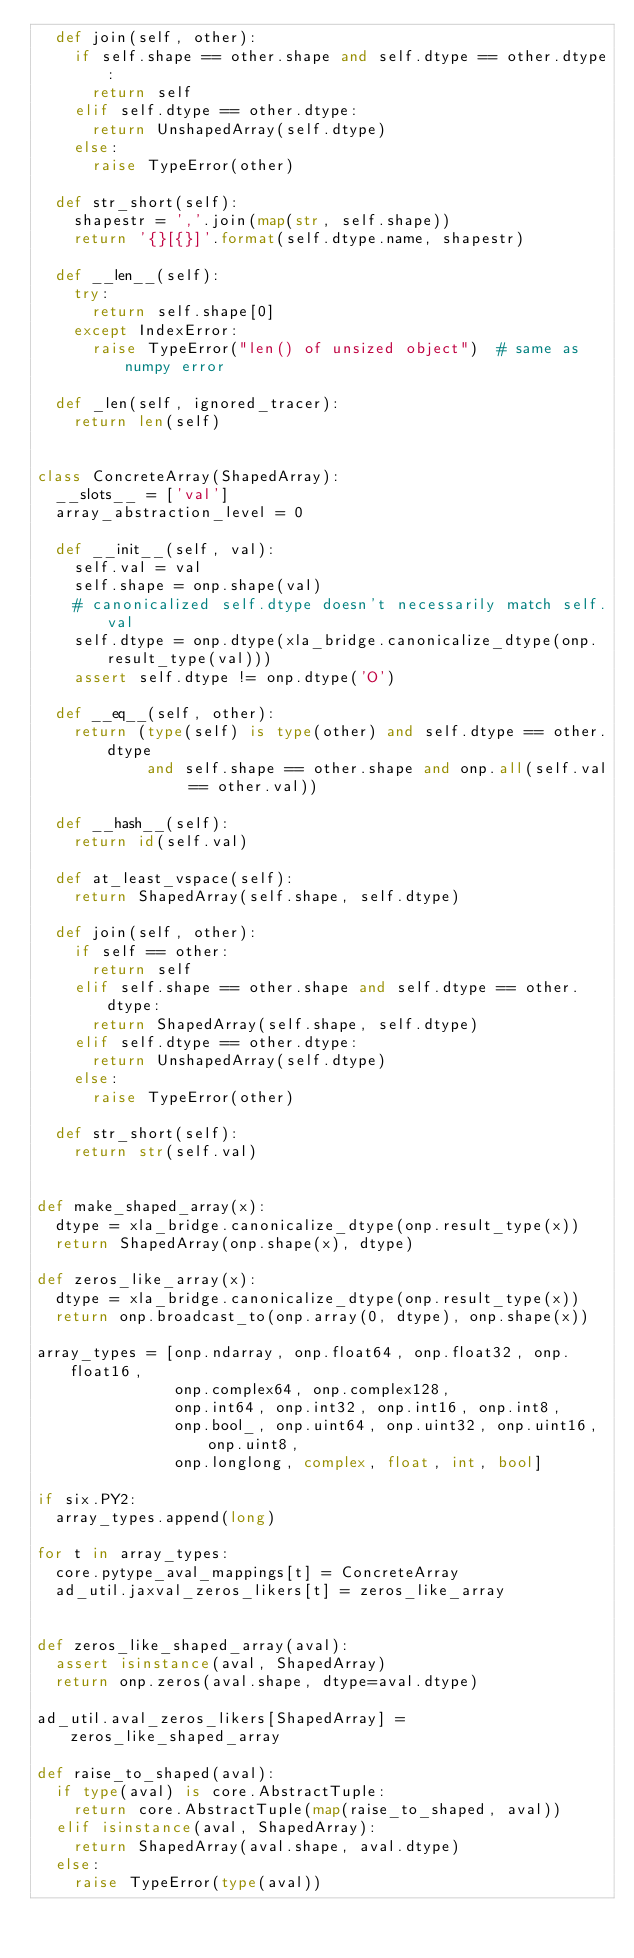<code> <loc_0><loc_0><loc_500><loc_500><_Python_>  def join(self, other):
    if self.shape == other.shape and self.dtype == other.dtype:
      return self
    elif self.dtype == other.dtype:
      return UnshapedArray(self.dtype)
    else:
      raise TypeError(other)

  def str_short(self):
    shapestr = ','.join(map(str, self.shape))
    return '{}[{}]'.format(self.dtype.name, shapestr)

  def __len__(self):
    try:
      return self.shape[0]
    except IndexError:
      raise TypeError("len() of unsized object")  # same as numpy error

  def _len(self, ignored_tracer):
    return len(self)


class ConcreteArray(ShapedArray):
  __slots__ = ['val']
  array_abstraction_level = 0

  def __init__(self, val):
    self.val = val
    self.shape = onp.shape(val)
    # canonicalized self.dtype doesn't necessarily match self.val
    self.dtype = onp.dtype(xla_bridge.canonicalize_dtype(onp.result_type(val)))
    assert self.dtype != onp.dtype('O')

  def __eq__(self, other):
    return (type(self) is type(other) and self.dtype == other.dtype
            and self.shape == other.shape and onp.all(self.val == other.val))

  def __hash__(self):
    return id(self.val)

  def at_least_vspace(self):
    return ShapedArray(self.shape, self.dtype)

  def join(self, other):
    if self == other:
      return self
    elif self.shape == other.shape and self.dtype == other.dtype:
      return ShapedArray(self.shape, self.dtype)
    elif self.dtype == other.dtype:
      return UnshapedArray(self.dtype)
    else:
      raise TypeError(other)

  def str_short(self):
    return str(self.val)


def make_shaped_array(x):
  dtype = xla_bridge.canonicalize_dtype(onp.result_type(x))
  return ShapedArray(onp.shape(x), dtype)

def zeros_like_array(x):
  dtype = xla_bridge.canonicalize_dtype(onp.result_type(x))
  return onp.broadcast_to(onp.array(0, dtype), onp.shape(x))

array_types = [onp.ndarray, onp.float64, onp.float32, onp.float16,
               onp.complex64, onp.complex128,
               onp.int64, onp.int32, onp.int16, onp.int8,
               onp.bool_, onp.uint64, onp.uint32, onp.uint16, onp.uint8,
               onp.longlong, complex, float, int, bool]

if six.PY2:
  array_types.append(long)

for t in array_types:
  core.pytype_aval_mappings[t] = ConcreteArray
  ad_util.jaxval_zeros_likers[t] = zeros_like_array


def zeros_like_shaped_array(aval):
  assert isinstance(aval, ShapedArray)
  return onp.zeros(aval.shape, dtype=aval.dtype)

ad_util.aval_zeros_likers[ShapedArray] = zeros_like_shaped_array

def raise_to_shaped(aval):
  if type(aval) is core.AbstractTuple:
    return core.AbstractTuple(map(raise_to_shaped, aval))
  elif isinstance(aval, ShapedArray):
    return ShapedArray(aval.shape, aval.dtype)
  else:
    raise TypeError(type(aval))
</code> 